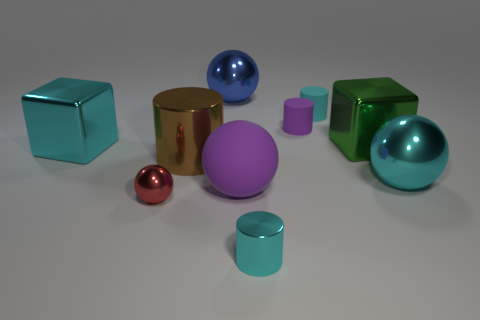There is a sphere that is the same color as the tiny metal cylinder; what size is it?
Offer a terse response. Large. How many other objects are the same color as the big matte ball?
Your response must be concise. 1. There is a cyan metallic object that is on the left side of the cyan rubber cylinder and on the right side of the large brown thing; what shape is it?
Provide a short and direct response. Cylinder. There is a cyan cylinder behind the metal cylinder that is on the left side of the blue metal ball; are there any big green cubes that are to the left of it?
Your answer should be very brief. No. What number of other objects are there of the same material as the green block?
Your answer should be compact. 6. What number of large blue metallic blocks are there?
Keep it short and to the point. 0. What number of objects are either brown cylinders or rubber things that are behind the big brown shiny object?
Ensure brevity in your answer.  3. Are there any other things that are the same shape as the blue object?
Your answer should be very brief. Yes. There is a purple thing in front of the green metal cube; is its size the same as the big cyan sphere?
Provide a succinct answer. Yes. How many metallic objects are either cyan cubes or large cyan objects?
Keep it short and to the point. 2. 